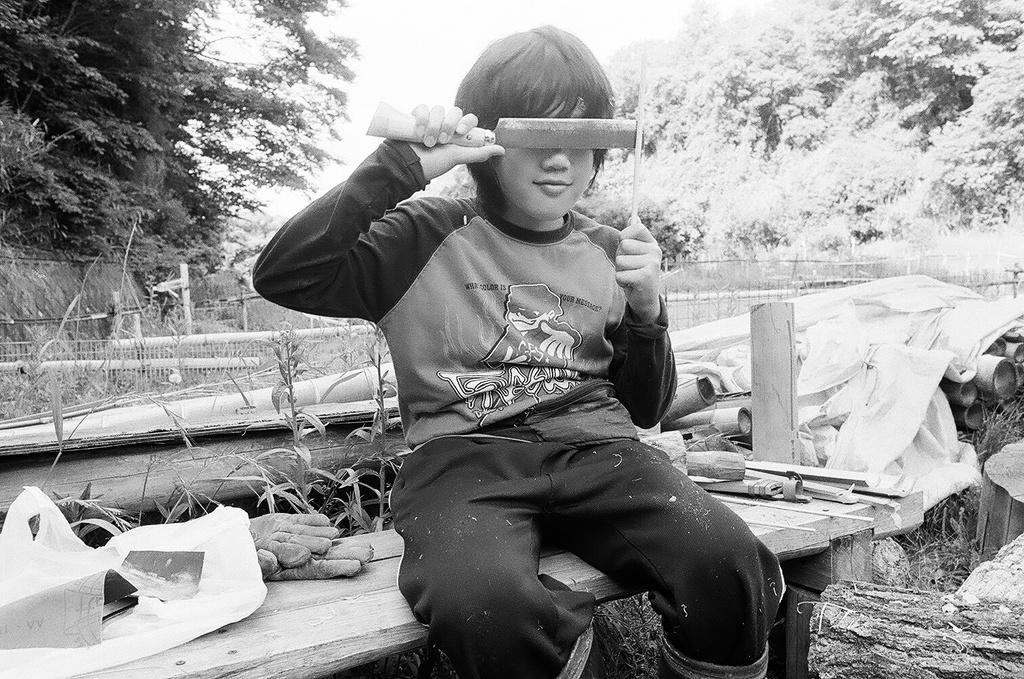What is the kid doing in the image? The kid is sitting on a bench in the image. What is the kid holding in the image? The kid is holding something in the image. What can be seen in the background of the image? There are trees in the background of the image. What type of material is visible in the image? There is a plastic cover visible in the image. How many gloves are present in the image? There are two gloves in the image. What type of magic trick is the kid performing in the image? There is no indication of a magic trick being performed in the image. The kid is simply sitting on a bench and holding something. 